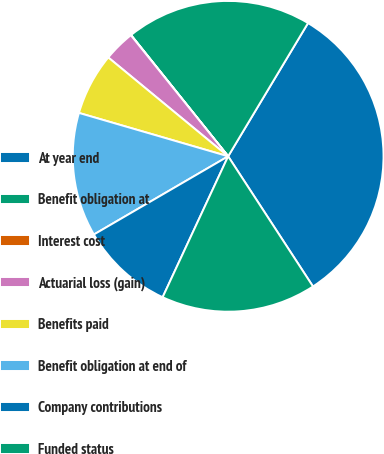Convert chart to OTSL. <chart><loc_0><loc_0><loc_500><loc_500><pie_chart><fcel>At year end<fcel>Benefit obligation at<fcel>Interest cost<fcel>Actuarial loss (gain)<fcel>Benefits paid<fcel>Benefit obligation at end of<fcel>Company contributions<fcel>Funded status<nl><fcel>32.21%<fcel>19.34%<fcel>0.03%<fcel>3.25%<fcel>6.47%<fcel>12.9%<fcel>9.68%<fcel>16.12%<nl></chart> 